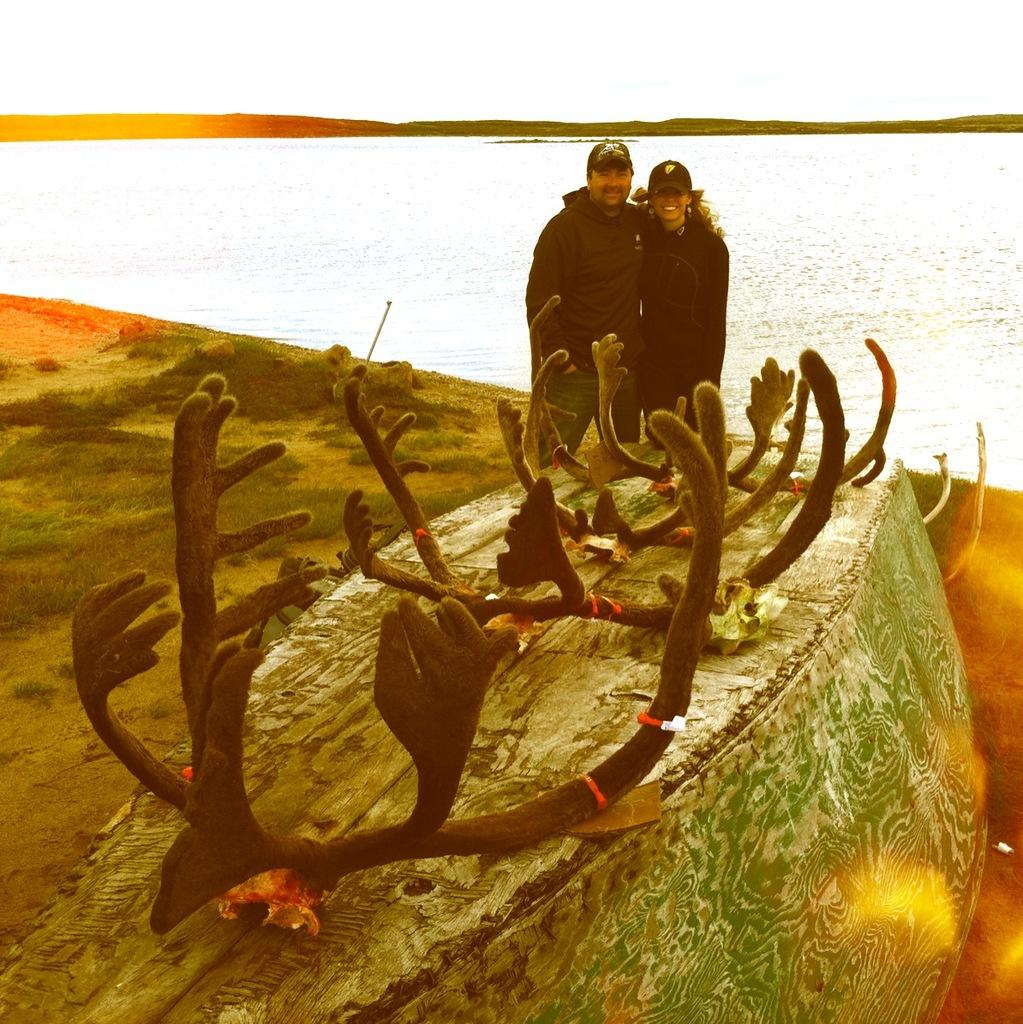How many people are in the foreground of the image? There are two persons standing in the foreground. What is the surface they are standing on? The persons are standing on grass. What else can be seen in the foreground besides the people? There are objects and water visible in the foreground. What is visible in the background of the image? There are trees and the sky visible in the background. Can you determine the time of day the image was taken? The image was likely taken during the day, as the sky is visible and there is no indication of darkness. What type of drum is being played by the person in the image? There is no drum present in the image; the persons are not playing any musical instruments. Can you see any gloves on the persons in the image? There are no gloves visible on the persons in the image. 